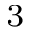<formula> <loc_0><loc_0><loc_500><loc_500>_ { 3 }</formula> 